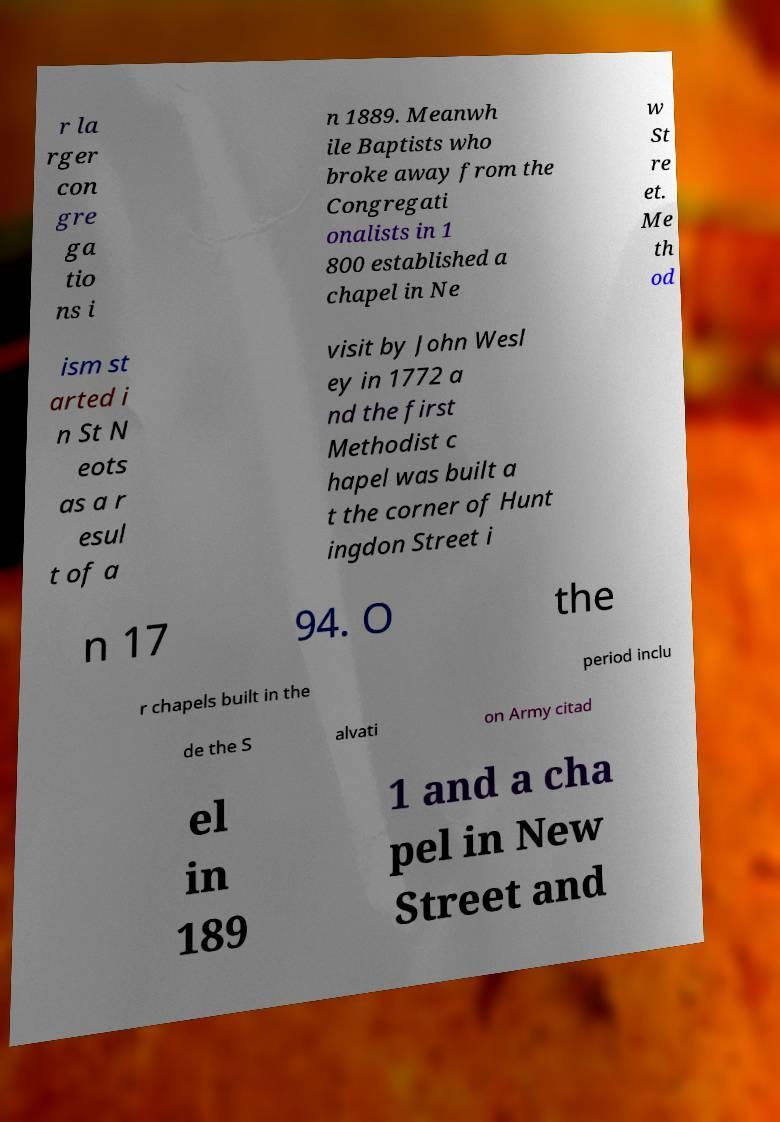I need the written content from this picture converted into text. Can you do that? r la rger con gre ga tio ns i n 1889. Meanwh ile Baptists who broke away from the Congregati onalists in 1 800 established a chapel in Ne w St re et. Me th od ism st arted i n St N eots as a r esul t of a visit by John Wesl ey in 1772 a nd the first Methodist c hapel was built a t the corner of Hunt ingdon Street i n 17 94. O the r chapels built in the period inclu de the S alvati on Army citad el in 189 1 and a cha pel in New Street and 